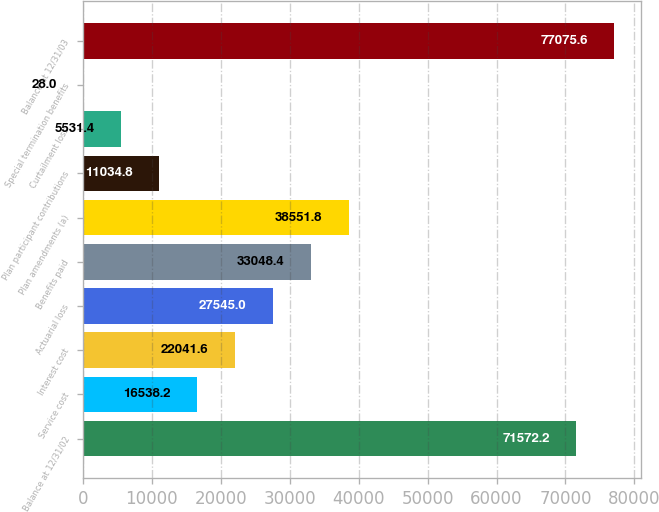Convert chart to OTSL. <chart><loc_0><loc_0><loc_500><loc_500><bar_chart><fcel>Balance at 12/31/02<fcel>Service cost<fcel>Interest cost<fcel>Actuarial loss<fcel>Benefits paid<fcel>Plan amendments (a)<fcel>Plan participant contributions<fcel>Curtailment loss<fcel>Special termination benefits<fcel>Balance at 12/31/03<nl><fcel>71572.2<fcel>16538.2<fcel>22041.6<fcel>27545<fcel>33048.4<fcel>38551.8<fcel>11034.8<fcel>5531.4<fcel>28<fcel>77075.6<nl></chart> 